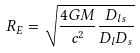Convert formula to latex. <formula><loc_0><loc_0><loc_500><loc_500>R _ { E } = \sqrt { \frac { 4 G M } { c ^ { 2 } } \frac { D _ { l s } } { D _ { l } D _ { s } } }</formula> 